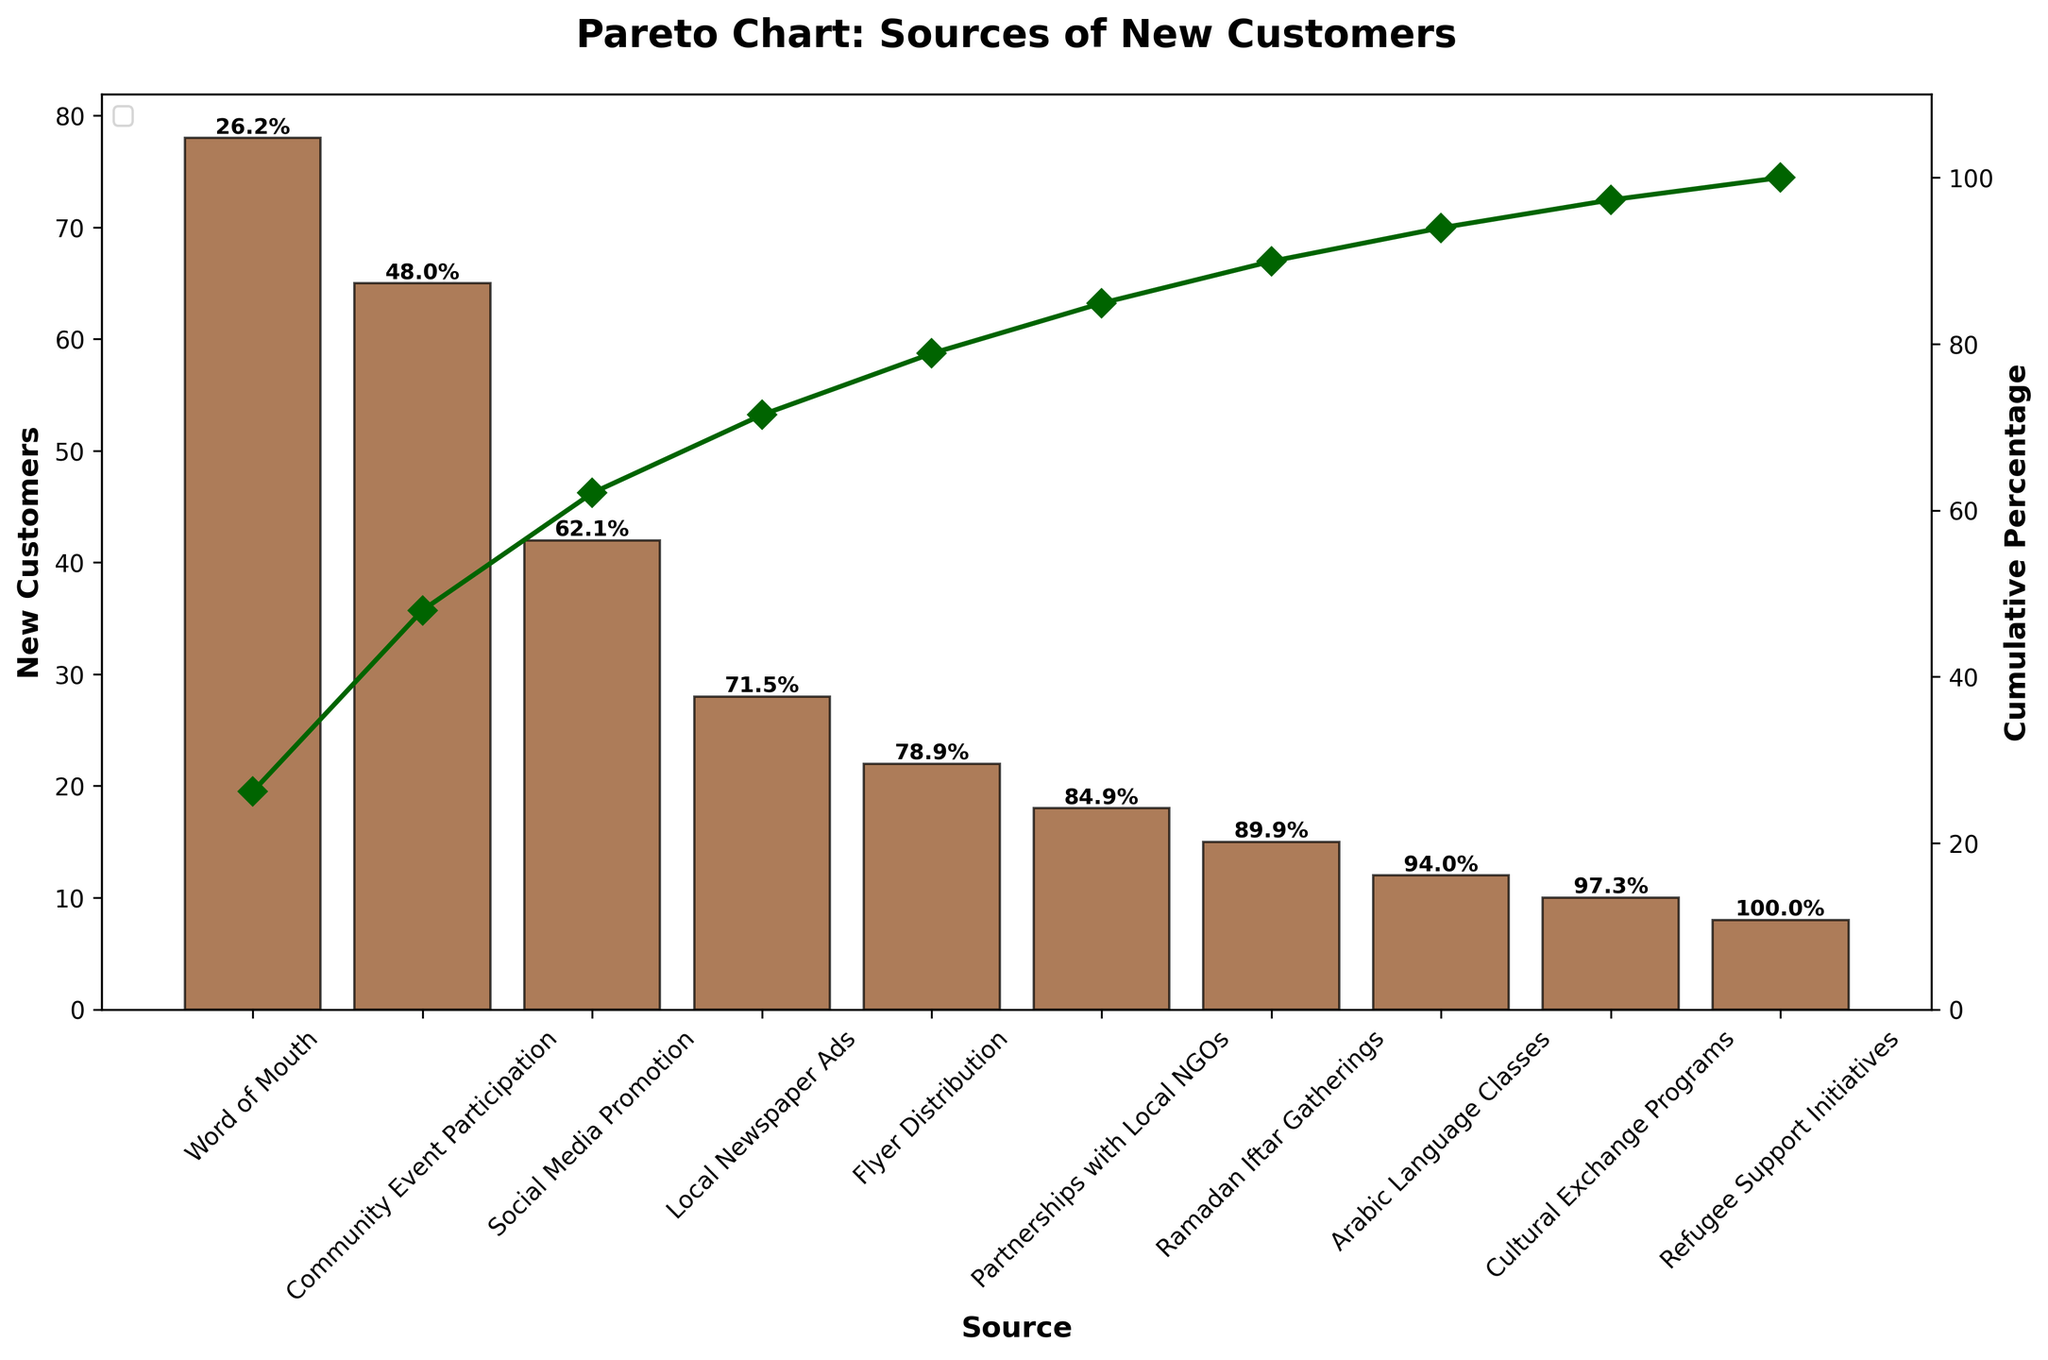What is the title of the Pareto Chart? The title is located at the top of the chart and provides a summary of the data being presented.
Answer: Pareto Chart: Sources of New Customers Which source brought in the highest number of new customers? By looking at the highest bar in the bar chart, you can identify the source with the most new customers.
Answer: Word of Mouth How many new customers were acquired through Social Media Promotion? Locate the bar labeled "Social Media Promotion" and read the value at its top.
Answer: 42 What percentage of new customers was acquired through the top three sources? The cumulative percentage above the third source (Social Media Promotion) will provide this information.
Answer: 74.4% Which sources contribute to the cumulative percentage reaching over 80%? Identify and count the bars, from highest to lowest, until the cumulative percentage exceeds 80%.
Answer: Word of Mouth, Community Event Participation, Social Media Promotion, Local Newspaper Ads What is the cumulative percentage after six sources? Look at the cumulative percentage label above the sixth bar.
Answer: 91.8% How does the number of new customers from Partnerships with Local NGOs compare to Ramadan Iftar Gatherings? Check and compare the heights of the bars for Partnerships with Local NGOs and Ramadan Iftar Gatherings.
Answer: Partnerships with Local NGOs (18) generated more new customers than Ramadan Iftar Gatherings (15) What is the least effective source in the chart? Identify the smallest bar, representing the source with the fewest new customers.
Answer: Refugee Support Initiatives What is the new customer difference between Flyer Distribution and Arabic Language Classes? Subtract the number of new customers of Arabic Language Classes from that of Flyer Distribution (22 - 12).
Answer: 10 What is the rate of increase in cumulative percentage from Cultural Exchange Programs to Refugee Support Initiatives? Find the cumulative percentages for both and calculate the difference (85.9% - 83.2%).
Answer: 2.7% 